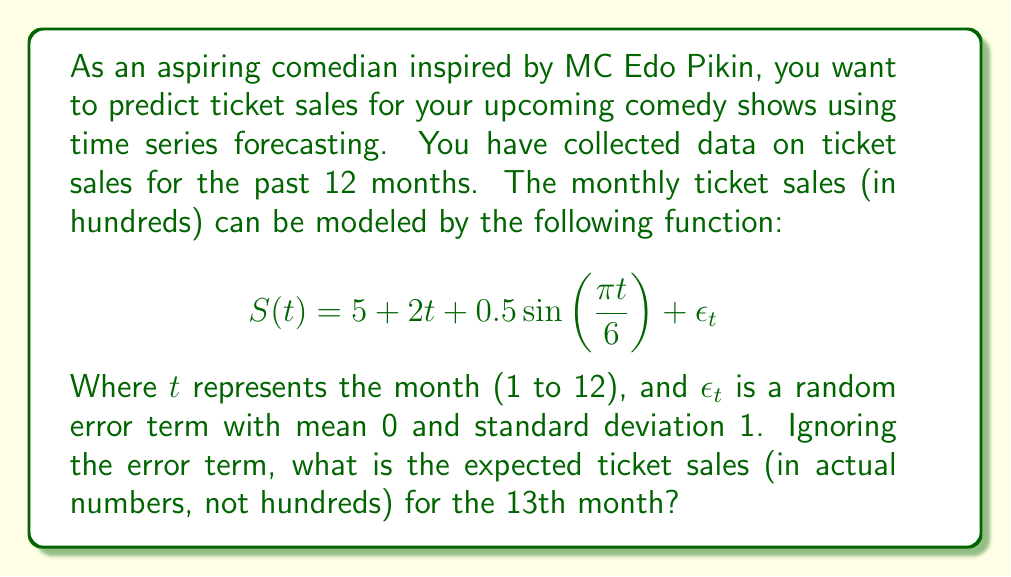Teach me how to tackle this problem. To solve this problem, we need to follow these steps:

1. Understand the components of the time series model:
   - Base level: 5 (hundred tickets)
   - Trend: $2t$ (increasing by 2 hundred tickets per month)
   - Seasonality: $0.5\sin(\frac{\pi t}{6})$ (seasonal fluctuation)

2. Substitute $t = 13$ into the function, ignoring the error term $\epsilon_t$:

   $$S(13) = 5 + 2(13) + 0.5\sin(\frac{\pi 13}{6})$$

3. Calculate each component:
   - Base level: 5
   - Trend: $2(13) = 26$
   - Seasonality: $0.5\sin(\frac{\pi 13}{6}) = 0.5\sin(\frac{13\pi}{6}) \approx 0.25$

4. Sum up the components:

   $$S(13) = 5 + 26 + 0.25 = 31.25$$

5. Convert the result from hundreds to actual ticket numbers:

   $$31.25 \times 100 = 3125$$

Therefore, the expected ticket sales for the 13th month is 3125 tickets.
Answer: 3125 tickets 